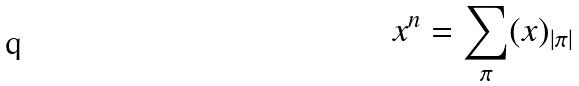Convert formula to latex. <formula><loc_0><loc_0><loc_500><loc_500>x ^ { n } = \sum _ { \pi } ( x ) _ { | \pi | }</formula> 